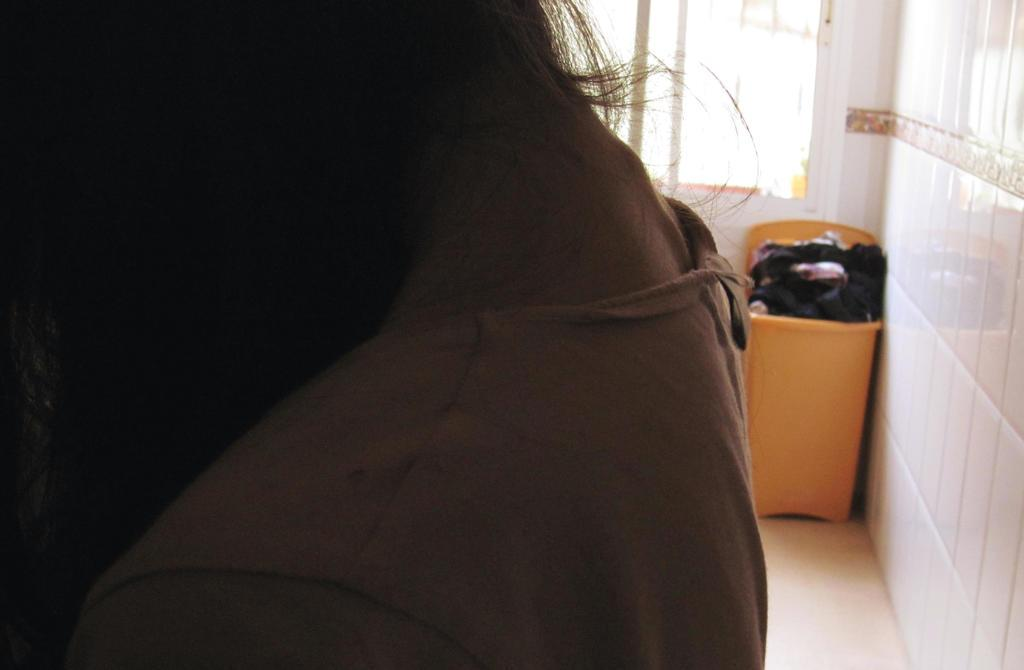What part of a woman's body is visible in the image? There is a woman's neck in the image. What is located on the right side of the image? There is a wall and a dustbin on the right side of the image. What is the surface beneath the woman's neck? There is a floor visible in the image. What can be seen through the window on the right side of the image? The image does not show what can be seen through the window. What type of hat is the dad wearing in the image? There is no dad or hat present in the image. 